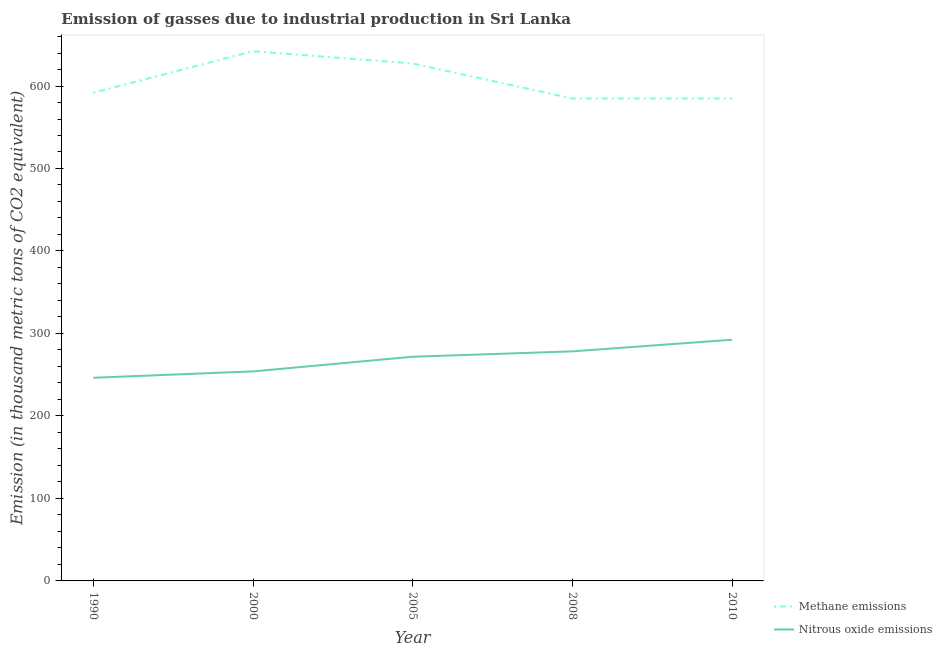How many different coloured lines are there?
Provide a short and direct response. 2. Does the line corresponding to amount of methane emissions intersect with the line corresponding to amount of nitrous oxide emissions?
Offer a terse response. No. Is the number of lines equal to the number of legend labels?
Your response must be concise. Yes. What is the amount of nitrous oxide emissions in 2010?
Give a very brief answer. 292.4. Across all years, what is the maximum amount of methane emissions?
Your answer should be compact. 642.2. Across all years, what is the minimum amount of methane emissions?
Offer a very short reply. 584.9. In which year was the amount of nitrous oxide emissions maximum?
Provide a succinct answer. 2010. What is the total amount of methane emissions in the graph?
Your answer should be compact. 3031.1. What is the difference between the amount of methane emissions in 2000 and that in 2008?
Offer a very short reply. 57.3. What is the difference between the amount of methane emissions in 2008 and the amount of nitrous oxide emissions in 2010?
Offer a terse response. 292.5. What is the average amount of methane emissions per year?
Your response must be concise. 606.22. In the year 2008, what is the difference between the amount of nitrous oxide emissions and amount of methane emissions?
Offer a very short reply. -306.6. In how many years, is the amount of nitrous oxide emissions greater than 640 thousand metric tons?
Ensure brevity in your answer.  0. What is the ratio of the amount of nitrous oxide emissions in 2005 to that in 2008?
Provide a short and direct response. 0.98. Is the amount of nitrous oxide emissions in 1990 less than that in 2010?
Provide a succinct answer. Yes. Is the difference between the amount of nitrous oxide emissions in 2005 and 2010 greater than the difference between the amount of methane emissions in 2005 and 2010?
Keep it short and to the point. No. What is the difference between the highest and the second highest amount of methane emissions?
Provide a succinct answer. 14.9. What is the difference between the highest and the lowest amount of nitrous oxide emissions?
Offer a terse response. 46.1. Is the sum of the amount of methane emissions in 2000 and 2005 greater than the maximum amount of nitrous oxide emissions across all years?
Your answer should be very brief. Yes. Does the amount of methane emissions monotonically increase over the years?
Your answer should be very brief. No. Is the amount of methane emissions strictly greater than the amount of nitrous oxide emissions over the years?
Give a very brief answer. Yes. Is the amount of nitrous oxide emissions strictly less than the amount of methane emissions over the years?
Make the answer very short. Yes. Are the values on the major ticks of Y-axis written in scientific E-notation?
Give a very brief answer. No. Does the graph contain any zero values?
Your answer should be compact. No. Where does the legend appear in the graph?
Your answer should be compact. Bottom right. What is the title of the graph?
Offer a very short reply. Emission of gasses due to industrial production in Sri Lanka. What is the label or title of the Y-axis?
Make the answer very short. Emission (in thousand metric tons of CO2 equivalent). What is the Emission (in thousand metric tons of CO2 equivalent) of Methane emissions in 1990?
Provide a short and direct response. 591.8. What is the Emission (in thousand metric tons of CO2 equivalent) in Nitrous oxide emissions in 1990?
Keep it short and to the point. 246.3. What is the Emission (in thousand metric tons of CO2 equivalent) of Methane emissions in 2000?
Offer a terse response. 642.2. What is the Emission (in thousand metric tons of CO2 equivalent) in Nitrous oxide emissions in 2000?
Your response must be concise. 254. What is the Emission (in thousand metric tons of CO2 equivalent) of Methane emissions in 2005?
Your response must be concise. 627.3. What is the Emission (in thousand metric tons of CO2 equivalent) in Nitrous oxide emissions in 2005?
Your response must be concise. 271.8. What is the Emission (in thousand metric tons of CO2 equivalent) in Methane emissions in 2008?
Your answer should be compact. 584.9. What is the Emission (in thousand metric tons of CO2 equivalent) in Nitrous oxide emissions in 2008?
Offer a very short reply. 278.3. What is the Emission (in thousand metric tons of CO2 equivalent) in Methane emissions in 2010?
Make the answer very short. 584.9. What is the Emission (in thousand metric tons of CO2 equivalent) in Nitrous oxide emissions in 2010?
Your answer should be very brief. 292.4. Across all years, what is the maximum Emission (in thousand metric tons of CO2 equivalent) of Methane emissions?
Provide a succinct answer. 642.2. Across all years, what is the maximum Emission (in thousand metric tons of CO2 equivalent) in Nitrous oxide emissions?
Offer a terse response. 292.4. Across all years, what is the minimum Emission (in thousand metric tons of CO2 equivalent) in Methane emissions?
Provide a short and direct response. 584.9. Across all years, what is the minimum Emission (in thousand metric tons of CO2 equivalent) in Nitrous oxide emissions?
Make the answer very short. 246.3. What is the total Emission (in thousand metric tons of CO2 equivalent) in Methane emissions in the graph?
Give a very brief answer. 3031.1. What is the total Emission (in thousand metric tons of CO2 equivalent) of Nitrous oxide emissions in the graph?
Keep it short and to the point. 1342.8. What is the difference between the Emission (in thousand metric tons of CO2 equivalent) in Methane emissions in 1990 and that in 2000?
Provide a short and direct response. -50.4. What is the difference between the Emission (in thousand metric tons of CO2 equivalent) of Methane emissions in 1990 and that in 2005?
Your answer should be very brief. -35.5. What is the difference between the Emission (in thousand metric tons of CO2 equivalent) of Nitrous oxide emissions in 1990 and that in 2005?
Your answer should be compact. -25.5. What is the difference between the Emission (in thousand metric tons of CO2 equivalent) in Methane emissions in 1990 and that in 2008?
Provide a short and direct response. 6.9. What is the difference between the Emission (in thousand metric tons of CO2 equivalent) of Nitrous oxide emissions in 1990 and that in 2008?
Offer a very short reply. -32. What is the difference between the Emission (in thousand metric tons of CO2 equivalent) of Methane emissions in 1990 and that in 2010?
Make the answer very short. 6.9. What is the difference between the Emission (in thousand metric tons of CO2 equivalent) in Nitrous oxide emissions in 1990 and that in 2010?
Offer a very short reply. -46.1. What is the difference between the Emission (in thousand metric tons of CO2 equivalent) in Methane emissions in 2000 and that in 2005?
Your answer should be compact. 14.9. What is the difference between the Emission (in thousand metric tons of CO2 equivalent) of Nitrous oxide emissions in 2000 and that in 2005?
Give a very brief answer. -17.8. What is the difference between the Emission (in thousand metric tons of CO2 equivalent) of Methane emissions in 2000 and that in 2008?
Provide a short and direct response. 57.3. What is the difference between the Emission (in thousand metric tons of CO2 equivalent) in Nitrous oxide emissions in 2000 and that in 2008?
Your answer should be compact. -24.3. What is the difference between the Emission (in thousand metric tons of CO2 equivalent) of Methane emissions in 2000 and that in 2010?
Offer a terse response. 57.3. What is the difference between the Emission (in thousand metric tons of CO2 equivalent) of Nitrous oxide emissions in 2000 and that in 2010?
Provide a succinct answer. -38.4. What is the difference between the Emission (in thousand metric tons of CO2 equivalent) of Methane emissions in 2005 and that in 2008?
Ensure brevity in your answer.  42.4. What is the difference between the Emission (in thousand metric tons of CO2 equivalent) of Methane emissions in 2005 and that in 2010?
Your response must be concise. 42.4. What is the difference between the Emission (in thousand metric tons of CO2 equivalent) of Nitrous oxide emissions in 2005 and that in 2010?
Provide a short and direct response. -20.6. What is the difference between the Emission (in thousand metric tons of CO2 equivalent) of Methane emissions in 2008 and that in 2010?
Give a very brief answer. 0. What is the difference between the Emission (in thousand metric tons of CO2 equivalent) in Nitrous oxide emissions in 2008 and that in 2010?
Make the answer very short. -14.1. What is the difference between the Emission (in thousand metric tons of CO2 equivalent) in Methane emissions in 1990 and the Emission (in thousand metric tons of CO2 equivalent) in Nitrous oxide emissions in 2000?
Your response must be concise. 337.8. What is the difference between the Emission (in thousand metric tons of CO2 equivalent) in Methane emissions in 1990 and the Emission (in thousand metric tons of CO2 equivalent) in Nitrous oxide emissions in 2005?
Give a very brief answer. 320. What is the difference between the Emission (in thousand metric tons of CO2 equivalent) of Methane emissions in 1990 and the Emission (in thousand metric tons of CO2 equivalent) of Nitrous oxide emissions in 2008?
Your answer should be very brief. 313.5. What is the difference between the Emission (in thousand metric tons of CO2 equivalent) of Methane emissions in 1990 and the Emission (in thousand metric tons of CO2 equivalent) of Nitrous oxide emissions in 2010?
Provide a short and direct response. 299.4. What is the difference between the Emission (in thousand metric tons of CO2 equivalent) in Methane emissions in 2000 and the Emission (in thousand metric tons of CO2 equivalent) in Nitrous oxide emissions in 2005?
Your response must be concise. 370.4. What is the difference between the Emission (in thousand metric tons of CO2 equivalent) of Methane emissions in 2000 and the Emission (in thousand metric tons of CO2 equivalent) of Nitrous oxide emissions in 2008?
Give a very brief answer. 363.9. What is the difference between the Emission (in thousand metric tons of CO2 equivalent) in Methane emissions in 2000 and the Emission (in thousand metric tons of CO2 equivalent) in Nitrous oxide emissions in 2010?
Provide a succinct answer. 349.8. What is the difference between the Emission (in thousand metric tons of CO2 equivalent) in Methane emissions in 2005 and the Emission (in thousand metric tons of CO2 equivalent) in Nitrous oxide emissions in 2008?
Your answer should be very brief. 349. What is the difference between the Emission (in thousand metric tons of CO2 equivalent) in Methane emissions in 2005 and the Emission (in thousand metric tons of CO2 equivalent) in Nitrous oxide emissions in 2010?
Your response must be concise. 334.9. What is the difference between the Emission (in thousand metric tons of CO2 equivalent) in Methane emissions in 2008 and the Emission (in thousand metric tons of CO2 equivalent) in Nitrous oxide emissions in 2010?
Ensure brevity in your answer.  292.5. What is the average Emission (in thousand metric tons of CO2 equivalent) in Methane emissions per year?
Give a very brief answer. 606.22. What is the average Emission (in thousand metric tons of CO2 equivalent) in Nitrous oxide emissions per year?
Offer a terse response. 268.56. In the year 1990, what is the difference between the Emission (in thousand metric tons of CO2 equivalent) of Methane emissions and Emission (in thousand metric tons of CO2 equivalent) of Nitrous oxide emissions?
Your response must be concise. 345.5. In the year 2000, what is the difference between the Emission (in thousand metric tons of CO2 equivalent) in Methane emissions and Emission (in thousand metric tons of CO2 equivalent) in Nitrous oxide emissions?
Your answer should be compact. 388.2. In the year 2005, what is the difference between the Emission (in thousand metric tons of CO2 equivalent) of Methane emissions and Emission (in thousand metric tons of CO2 equivalent) of Nitrous oxide emissions?
Your response must be concise. 355.5. In the year 2008, what is the difference between the Emission (in thousand metric tons of CO2 equivalent) in Methane emissions and Emission (in thousand metric tons of CO2 equivalent) in Nitrous oxide emissions?
Your response must be concise. 306.6. In the year 2010, what is the difference between the Emission (in thousand metric tons of CO2 equivalent) of Methane emissions and Emission (in thousand metric tons of CO2 equivalent) of Nitrous oxide emissions?
Your response must be concise. 292.5. What is the ratio of the Emission (in thousand metric tons of CO2 equivalent) in Methane emissions in 1990 to that in 2000?
Your answer should be compact. 0.92. What is the ratio of the Emission (in thousand metric tons of CO2 equivalent) in Nitrous oxide emissions in 1990 to that in 2000?
Your answer should be compact. 0.97. What is the ratio of the Emission (in thousand metric tons of CO2 equivalent) of Methane emissions in 1990 to that in 2005?
Provide a short and direct response. 0.94. What is the ratio of the Emission (in thousand metric tons of CO2 equivalent) in Nitrous oxide emissions in 1990 to that in 2005?
Offer a terse response. 0.91. What is the ratio of the Emission (in thousand metric tons of CO2 equivalent) of Methane emissions in 1990 to that in 2008?
Your answer should be very brief. 1.01. What is the ratio of the Emission (in thousand metric tons of CO2 equivalent) of Nitrous oxide emissions in 1990 to that in 2008?
Your answer should be very brief. 0.89. What is the ratio of the Emission (in thousand metric tons of CO2 equivalent) in Methane emissions in 1990 to that in 2010?
Provide a succinct answer. 1.01. What is the ratio of the Emission (in thousand metric tons of CO2 equivalent) of Nitrous oxide emissions in 1990 to that in 2010?
Provide a short and direct response. 0.84. What is the ratio of the Emission (in thousand metric tons of CO2 equivalent) of Methane emissions in 2000 to that in 2005?
Ensure brevity in your answer.  1.02. What is the ratio of the Emission (in thousand metric tons of CO2 equivalent) of Nitrous oxide emissions in 2000 to that in 2005?
Ensure brevity in your answer.  0.93. What is the ratio of the Emission (in thousand metric tons of CO2 equivalent) in Methane emissions in 2000 to that in 2008?
Your answer should be compact. 1.1. What is the ratio of the Emission (in thousand metric tons of CO2 equivalent) in Nitrous oxide emissions in 2000 to that in 2008?
Give a very brief answer. 0.91. What is the ratio of the Emission (in thousand metric tons of CO2 equivalent) of Methane emissions in 2000 to that in 2010?
Keep it short and to the point. 1.1. What is the ratio of the Emission (in thousand metric tons of CO2 equivalent) in Nitrous oxide emissions in 2000 to that in 2010?
Provide a succinct answer. 0.87. What is the ratio of the Emission (in thousand metric tons of CO2 equivalent) in Methane emissions in 2005 to that in 2008?
Your answer should be very brief. 1.07. What is the ratio of the Emission (in thousand metric tons of CO2 equivalent) of Nitrous oxide emissions in 2005 to that in 2008?
Your answer should be compact. 0.98. What is the ratio of the Emission (in thousand metric tons of CO2 equivalent) of Methane emissions in 2005 to that in 2010?
Your answer should be compact. 1.07. What is the ratio of the Emission (in thousand metric tons of CO2 equivalent) in Nitrous oxide emissions in 2005 to that in 2010?
Ensure brevity in your answer.  0.93. What is the ratio of the Emission (in thousand metric tons of CO2 equivalent) of Nitrous oxide emissions in 2008 to that in 2010?
Make the answer very short. 0.95. What is the difference between the highest and the second highest Emission (in thousand metric tons of CO2 equivalent) in Methane emissions?
Offer a terse response. 14.9. What is the difference between the highest and the second highest Emission (in thousand metric tons of CO2 equivalent) of Nitrous oxide emissions?
Make the answer very short. 14.1. What is the difference between the highest and the lowest Emission (in thousand metric tons of CO2 equivalent) in Methane emissions?
Your answer should be very brief. 57.3. What is the difference between the highest and the lowest Emission (in thousand metric tons of CO2 equivalent) of Nitrous oxide emissions?
Make the answer very short. 46.1. 